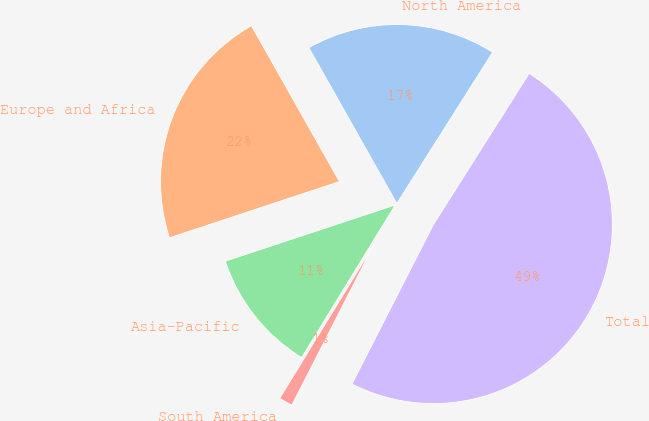<chart> <loc_0><loc_0><loc_500><loc_500><pie_chart><fcel>North America<fcel>Europe and Africa<fcel>Asia-Pacific<fcel>South America<fcel>Total<nl><fcel>17.17%<fcel>21.9%<fcel>11.16%<fcel>1.24%<fcel>48.53%<nl></chart> 